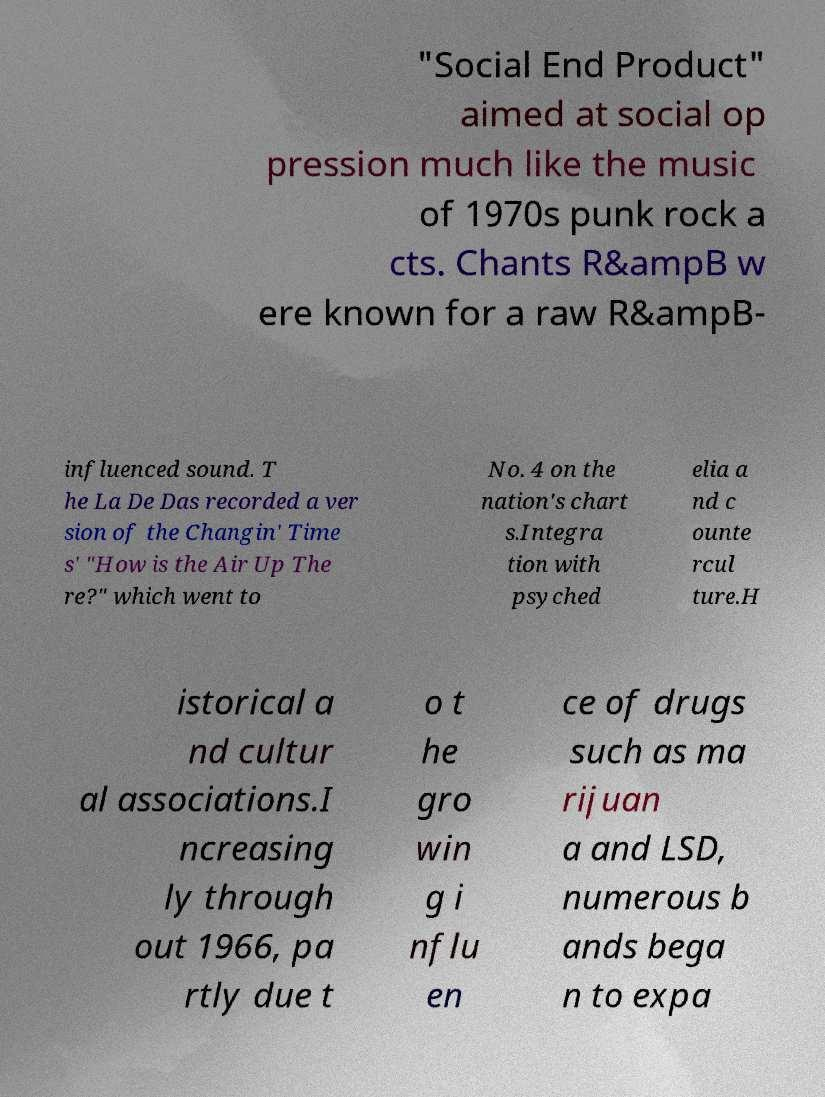Could you extract and type out the text from this image? "Social End Product" aimed at social op pression much like the music of 1970s punk rock a cts. Chants R&ampB w ere known for a raw R&ampB- influenced sound. T he La De Das recorded a ver sion of the Changin' Time s' "How is the Air Up The re?" which went to No. 4 on the nation's chart s.Integra tion with psyched elia a nd c ounte rcul ture.H istorical a nd cultur al associations.I ncreasing ly through out 1966, pa rtly due t o t he gro win g i nflu en ce of drugs such as ma rijuan a and LSD, numerous b ands bega n to expa 